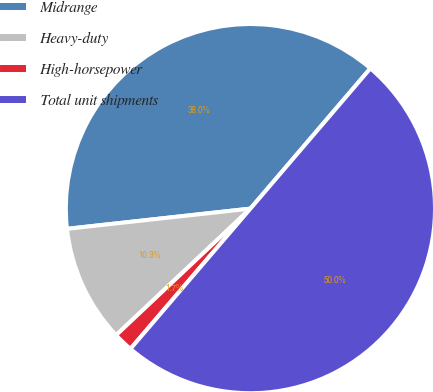Convert chart to OTSL. <chart><loc_0><loc_0><loc_500><loc_500><pie_chart><fcel>Midrange<fcel>Heavy-duty<fcel>High-horsepower<fcel>Total unit shipments<nl><fcel>38.01%<fcel>10.28%<fcel>1.71%<fcel>50.0%<nl></chart> 